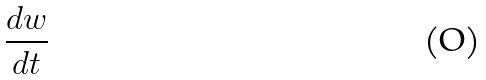Convert formula to latex. <formula><loc_0><loc_0><loc_500><loc_500>\frac { d w } { d t }</formula> 